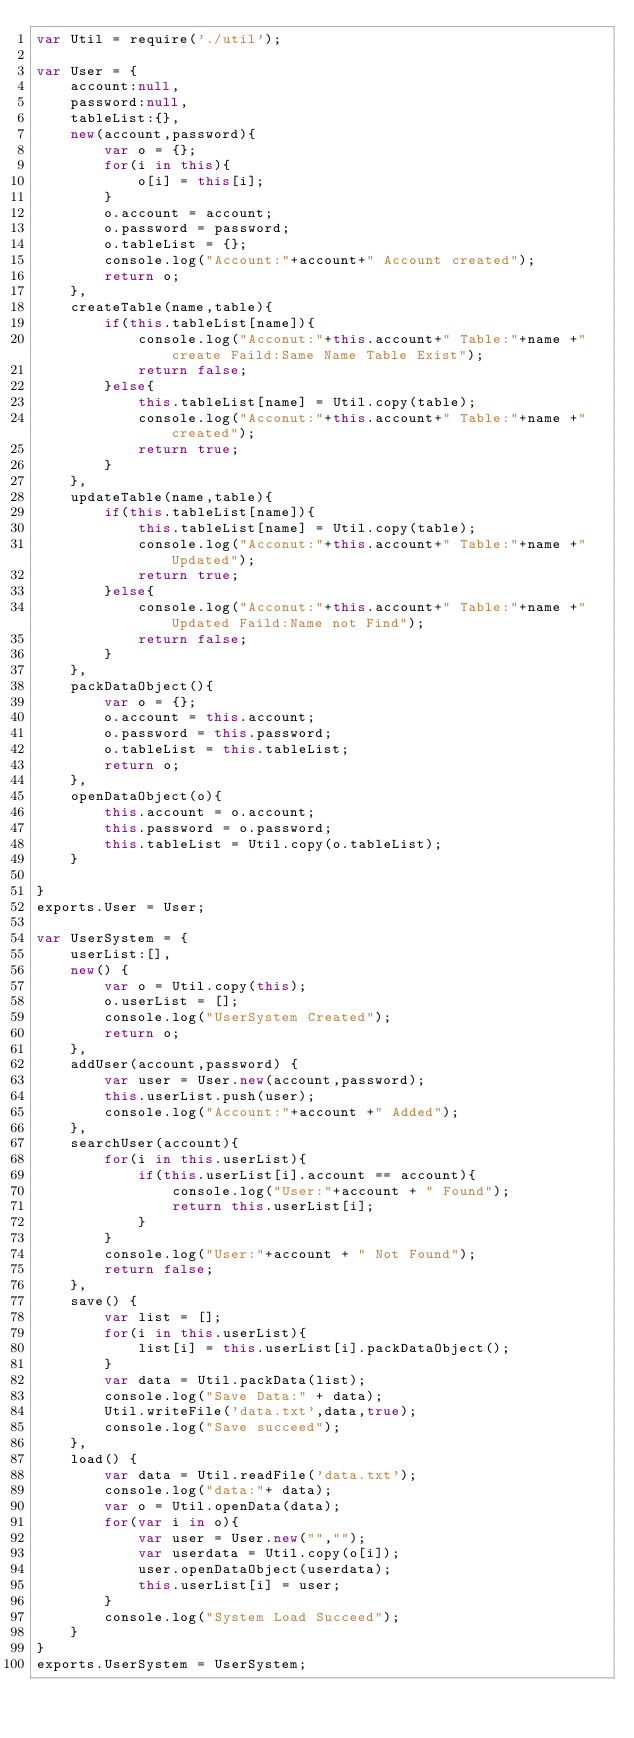<code> <loc_0><loc_0><loc_500><loc_500><_JavaScript_>var Util = require('./util');

var User = {
    account:null,
    password:null,
    tableList:{},
    new(account,password){
        var o = {};
        for(i in this){
            o[i] = this[i];
        }
        o.account = account;
        o.password = password;
        o.tableList = {};
        console.log("Account:"+account+" Account created");
        return o;
    },
    createTable(name,table){
        if(this.tableList[name]){
            console.log("Acconut:"+this.account+" Table:"+name +" create Faild:Same Name Table Exist");
            return false;
        }else{
            this.tableList[name] = Util.copy(table);
            console.log("Acconut:"+this.account+" Table:"+name +" created");
            return true;
        }  
    },
    updateTable(name,table){
        if(this.tableList[name]){
            this.tableList[name] = Util.copy(table);
            console.log("Acconut:"+this.account+" Table:"+name +" Updated");
            return true;
        }else{
            console.log("Acconut:"+this.account+" Table:"+name +" Updated Faild:Name not Find");
            return false;
        } 
    },
    packDataObject(){
        var o = {};
        o.account = this.account;
        o.password = this.password;
        o.tableList = this.tableList;
        return o;
    },
    openDataObject(o){
        this.account = o.account;
        this.password = o.password;
        this.tableList = Util.copy(o.tableList);
    }   
    
}
exports.User = User;

var UserSystem = {
    userList:[],
    new() {
        var o = Util.copy(this);
        o.userList = [];
        console.log("UserSystem Created");
        return o;
    },
    addUser(account,password) {
        var user = User.new(account,password);
        this.userList.push(user);
        console.log("Account:"+account +" Added");
    },
    searchUser(account){
        for(i in this.userList){
            if(this.userList[i].account == account){
                console.log("User:"+account + " Found");
                return this.userList[i];
            }
        }
        console.log("User:"+account + " Not Found");
        return false;
    },
    save() {
        var list = [];
        for(i in this.userList){
            list[i] = this.userList[i].packDataObject();
        }
        var data = Util.packData(list);
        console.log("Save Data:" + data);
        Util.writeFile('data.txt',data,true);
        console.log("Save succeed");
    },
    load() {
        var data = Util.readFile('data.txt');
        console.log("data:"+ data);
        var o = Util.openData(data);
        for(var i in o){
            var user = User.new("","");
            var userdata = Util.copy(o[i]);
            user.openDataObject(userdata);
            this.userList[i] = user;
        }
        console.log("System Load Succeed");
    }
}
exports.UserSystem = UserSystem;



</code> 